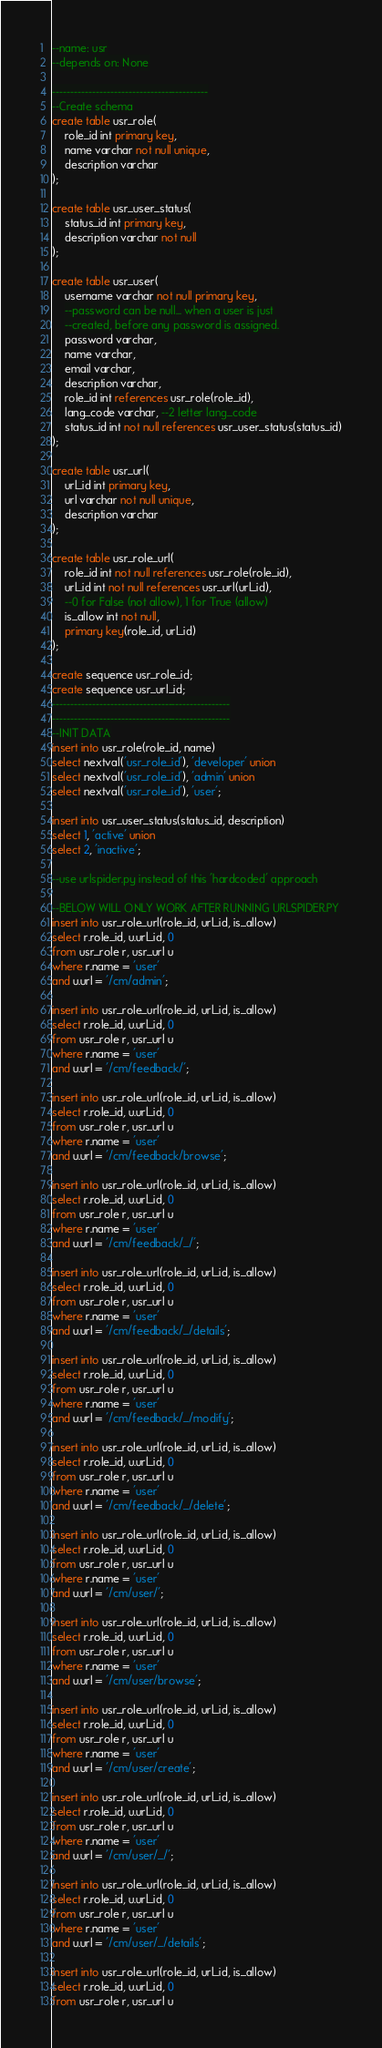Convert code to text. <code><loc_0><loc_0><loc_500><loc_500><_SQL_>--name: usr
--depends on: None

-------------------------------------------
--Create schema
create table usr_role(
	role_id int primary key,
	name varchar not null unique,
	description varchar
);

create table usr_user_status(
	status_id int primary key,
	description varchar not null
);

create table usr_user(
	username varchar not null primary key,
	--password can be null... when a user is just
	--created, before any password is assigned.
	password varchar,
	name varchar,	
	email varchar,
	description varchar,
	role_id int references usr_role(role_id),
	lang_code varchar, --2 letter lang_code
	status_id int not null references usr_user_status(status_id)
);

create table usr_url(
	url_id int primary key,
	url varchar not null unique,
	description varchar
);	

create table usr_role_url(
	role_id int not null references usr_role(role_id),
	url_id int not null references usr_url(url_id),
	--0 for False (not allow), 1 for True (allow)
	is_allow int not null,
	primary key(role_id, url_id)
);

create sequence usr_role_id;
create sequence usr_url_id;
-------------------------------------------------
-------------------------------------------------
--INIT DATA
insert into usr_role(role_id, name)
select nextval('usr_role_id'), 'developer' union
select nextval('usr_role_id'), 'admin' union
select nextval('usr_role_id'), 'user';

insert into usr_user_status(status_id, description)
select 1, 'active' union
select 2, 'inactive';

--use urlspider.py instead of this 'hardcoded' approach

--BELOW WILL ONLY WORK AFTER RUNNING URLSPIDER.PY
insert into usr_role_url(role_id, url_id, is_allow)
select r.role_id, u.url_id, 0
from usr_role r, usr_url u
where r.name = 'user'
and u.url = '/cm/admin';

insert into usr_role_url(role_id, url_id, is_allow)
select r.role_id, u.url_id, 0
from usr_role r, usr_url u
where r.name = 'user'
and u.url = '/cm/feedback/';

insert into usr_role_url(role_id, url_id, is_allow)
select r.role_id, u.url_id, 0
from usr_role r, usr_url u
where r.name = 'user'
and u.url = '/cm/feedback/browse';

insert into usr_role_url(role_id, url_id, is_allow)
select r.role_id, u.url_id, 0
from usr_role r, usr_url u
where r.name = 'user'
and u.url = '/cm/feedback/_/';

insert into usr_role_url(role_id, url_id, is_allow)
select r.role_id, u.url_id, 0
from usr_role r, usr_url u
where r.name = 'user'
and u.url = '/cm/feedback/_/details';

insert into usr_role_url(role_id, url_id, is_allow)
select r.role_id, u.url_id, 0
from usr_role r, usr_url u
where r.name = 'user'
and u.url = '/cm/feedback/_/modify';

insert into usr_role_url(role_id, url_id, is_allow)
select r.role_id, u.url_id, 0
from usr_role r, usr_url u
where r.name = 'user'
and u.url = '/cm/feedback/_/delete';

insert into usr_role_url(role_id, url_id, is_allow)
select r.role_id, u.url_id, 0
from usr_role r, usr_url u
where r.name = 'user'
and u.url = '/cm/user/';

insert into usr_role_url(role_id, url_id, is_allow)
select r.role_id, u.url_id, 0
from usr_role r, usr_url u
where r.name = 'user'
and u.url = '/cm/user/browse';

insert into usr_role_url(role_id, url_id, is_allow)
select r.role_id, u.url_id, 0
from usr_role r, usr_url u
where r.name = 'user'
and u.url = '/cm/user/create';

insert into usr_role_url(role_id, url_id, is_allow)
select r.role_id, u.url_id, 0
from usr_role r, usr_url u
where r.name = 'user'
and u.url = '/cm/user/_/';

insert into usr_role_url(role_id, url_id, is_allow)
select r.role_id, u.url_id, 0
from usr_role r, usr_url u
where r.name = 'user'
and u.url = '/cm/user/_/details';

insert into usr_role_url(role_id, url_id, is_allow)
select r.role_id, u.url_id, 0
from usr_role r, usr_url u</code> 